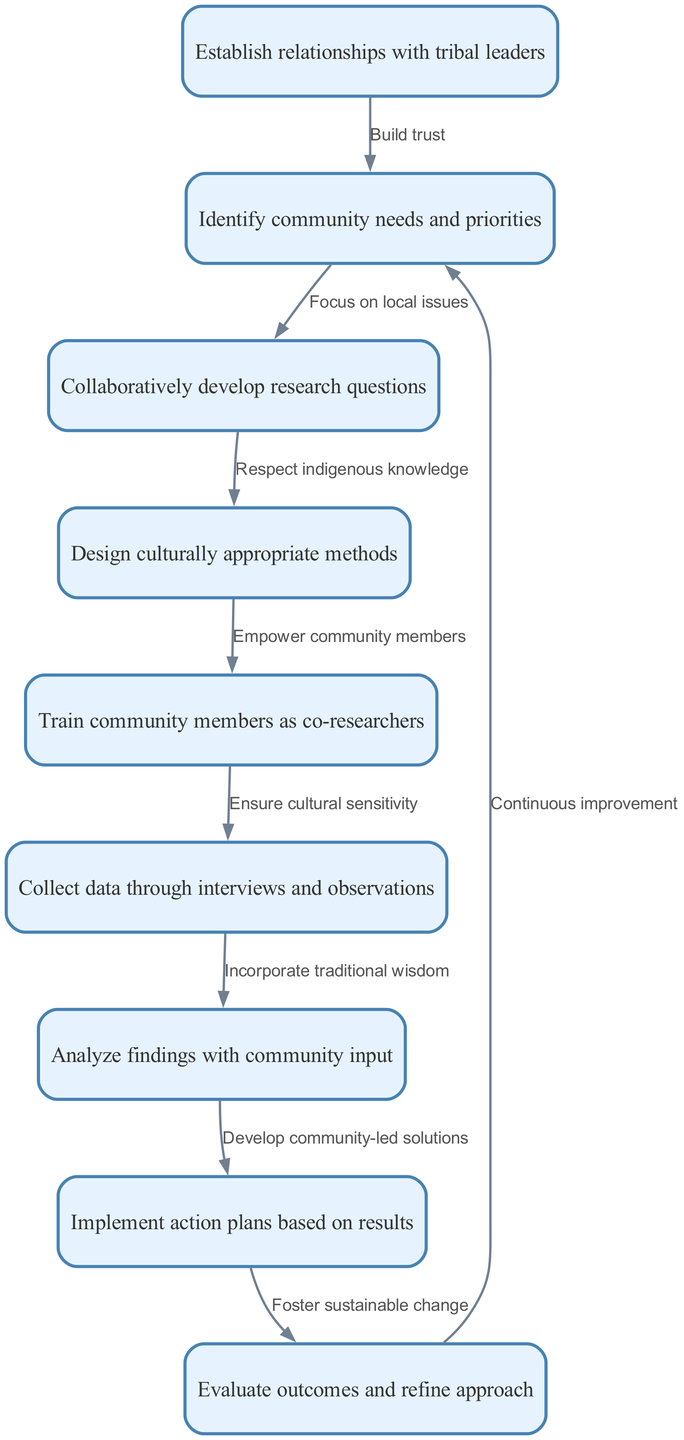what's the first step in conducting participatory action research? The diagram shows that the first step is to "Establish relationships with tribal leaders." This information is located at the top of the flowchart, indicating the initial action to initiate the research process.
Answer: Establish relationships with tribal leaders how many nodes are there in the diagram? The diagram lists a total of 9 distinct nodes representing steps in the participatory action research process. This can be counted from the provided nodes data.
Answer: 9 what is the final step of the flowchart? According to the diagram, the final step is "Evaluate outcomes and refine approach," which is positioned at the bottom of the flowchart and ends the participatory action research cycle.
Answer: Evaluate outcomes and refine approach which two steps focus on community involvement? The steps "Train community members as co-researchers" (node 5) and "Analyze findings with community input" (node 7) both emphasize community involvement in the research process, as they directly involve community members in important aspects of the research.
Answer: Train community members as co-researchers, Analyze findings with community input what relationship connects the design of methods to training community members? The relationship that connects these two nodes is described as "Empower community members." This indicates that designing culturally appropriate methods (node 4) is followed by training the community as co-researchers (node 5), emphasizing the empowerment aspect.
Answer: Empower community members which node incorporates traditional wisdom in the research? The diagram shows that the step "Collect data through interviews and observations" incorporates traditional wisdom, as indicated by the connecting edge text linking this step with community input.
Answer: Collect data through interviews and observations how does the research process foster sustainable change? The research process fosters sustainable change through the implementation of action plans based on results (node 8), which is directly tied to the goal of creating long-lasting impacts in the community. The flowchart illustrates this transition towards sustainability in the latter part of the process.
Answer: Implement action plans based on results what does the edge between "Evaluate outcomes and refine approach" and "Identify community needs and priorities" signify? The edge signifies "Continuous improvement," indicating that the evaluation of outcomes leads back to re-identifying community needs, promoting an iterative process for enhancing the research impact and relevance to the community.
Answer: Continuous improvement 